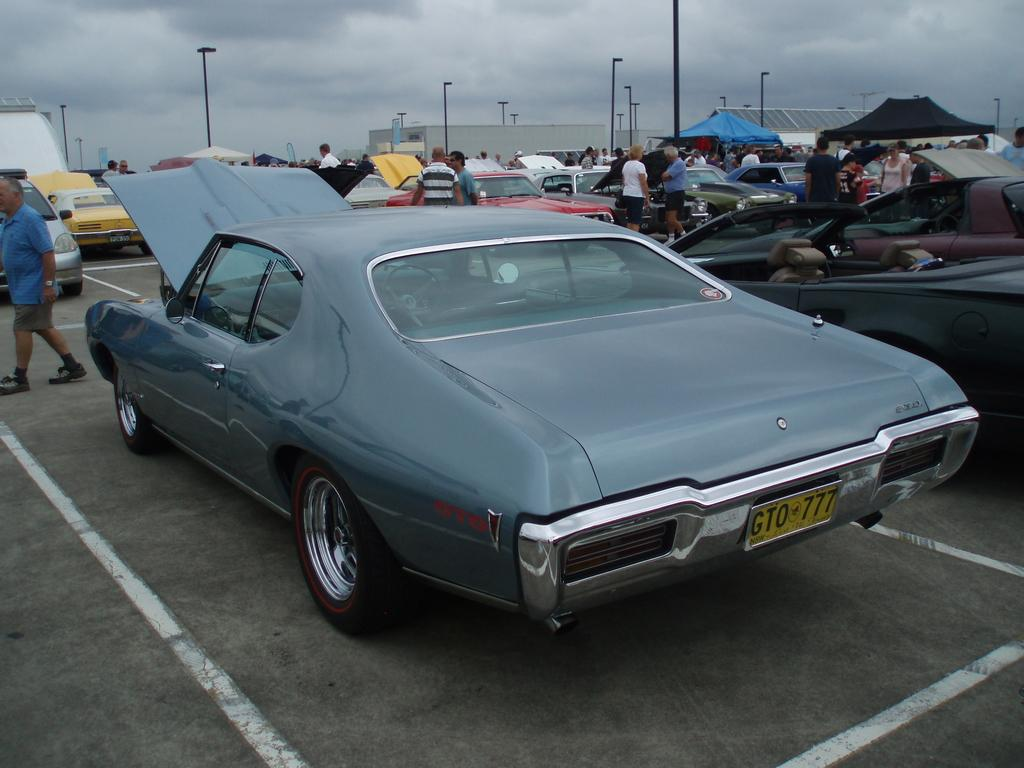What is the main subject in the center of the image? There are cars on the road in the center of the image. What can be seen in the background of the image? In the background, there are persons visible, additional cars, buildings, poles, and the sky. What is the condition of the sky in the image? The sky is visible in the background, and clouds are present in the sky. How many fingers can be seen pointing at the cars in the image? There are no fingers visible in the image, as it primarily features cars, roads, and background elements. --- Facts: 1. There is a person holding a book in the image. 2. The person is sitting on a chair. 3. The chair is in front of a table. 4. There is a lamp on the table. 5. The background of the image is a wall. Absurd Topics: elephant, ocean, bicycle Conversation: What is the person in the image holding? The person is holding a book in the image. What is the person sitting on? The person is sitting on a chair in the image. Where is the chair located in relation to the table? The chair is in front of a table in the image. What is on the table in the image? There is a lamp on the table in the image. What can be seen in the background of the image? The background of the image is a wall. Reasoning: Let's think step by step in order to produce the conversation. We start by identifying the main subject in the image, which is the person holding a book. Then, we expand the conversation to include other elements visible in the image, such as the chair, table, lamp, and the wall in the background. Each question is designed to elicit a specific detail about the image that is known from the provided facts. Absurd Question/Answer: Can you see any elephants or oceans in the image? No, there are no elephants or oceans present in the image. 